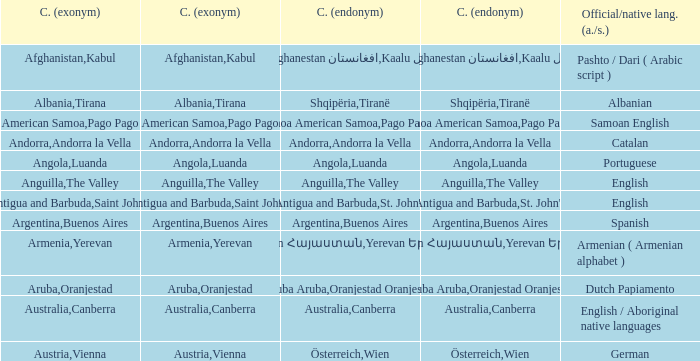What is the English name given to the city of St. John's? Saint John's. Could you help me parse every detail presented in this table? {'header': ['C. (exonym)', 'C. (exonym)', 'C. (endonym)', 'C. (endonym)', 'Official/native lang. (a./s.)'], 'rows': [['Afghanistan', 'Kabul', 'Afghanestan افغانستان', 'Kaalu كابل', 'Pashto / Dari ( Arabic script )'], ['Albania', 'Tirana', 'Shqipëria', 'Tiranë', 'Albanian'], ['American Samoa', 'Pago Pago', 'Amerika Sāmoa American Samoa', 'Pago Pago Pago Pago', 'Samoan English'], ['Andorra', 'Andorra la Vella', 'Andorra', 'Andorra la Vella', 'Catalan'], ['Angola', 'Luanda', 'Angola', 'Luanda', 'Portuguese'], ['Anguilla', 'The Valley', 'Anguilla', 'The Valley', 'English'], ['Antigua and Barbuda', "Saint John's", 'Antigua and Barbuda', "St. John's", 'English'], ['Argentina', 'Buenos Aires', 'Argentina', 'Buenos Aires', 'Spanish'], ['Armenia', 'Yerevan', 'Hayastán Հայաստան', 'Yerevan Երեվան', 'Armenian ( Armenian alphabet )'], ['Aruba', 'Oranjestad', 'Aruba Aruba', 'Oranjestad Oranjestad', 'Dutch Papiamento'], ['Australia', 'Canberra', 'Australia', 'Canberra', 'English / Aboriginal native languages'], ['Austria', 'Vienna', 'Österreich', 'Wien', 'German']]} 